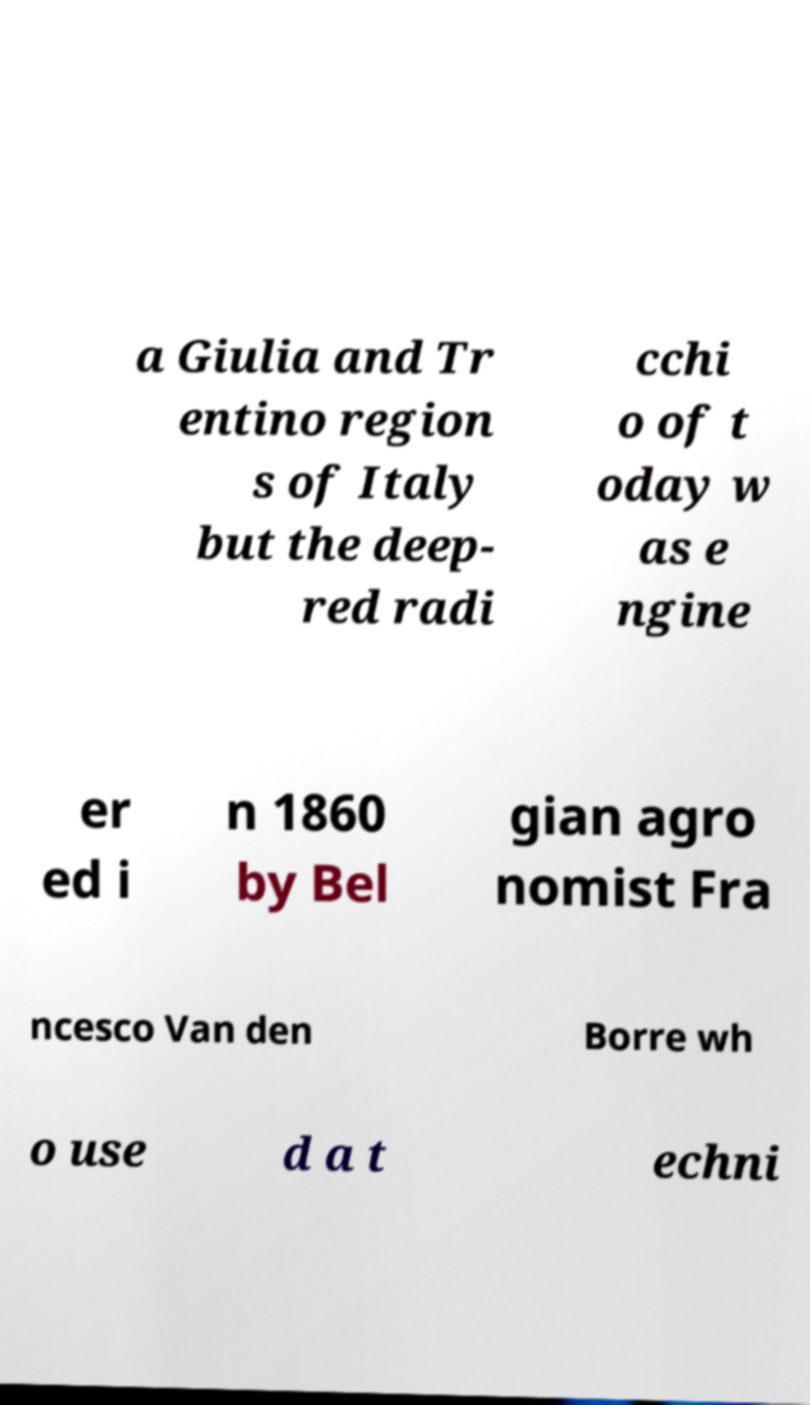What messages or text are displayed in this image? I need them in a readable, typed format. a Giulia and Tr entino region s of Italy but the deep- red radi cchi o of t oday w as e ngine er ed i n 1860 by Bel gian agro nomist Fra ncesco Van den Borre wh o use d a t echni 